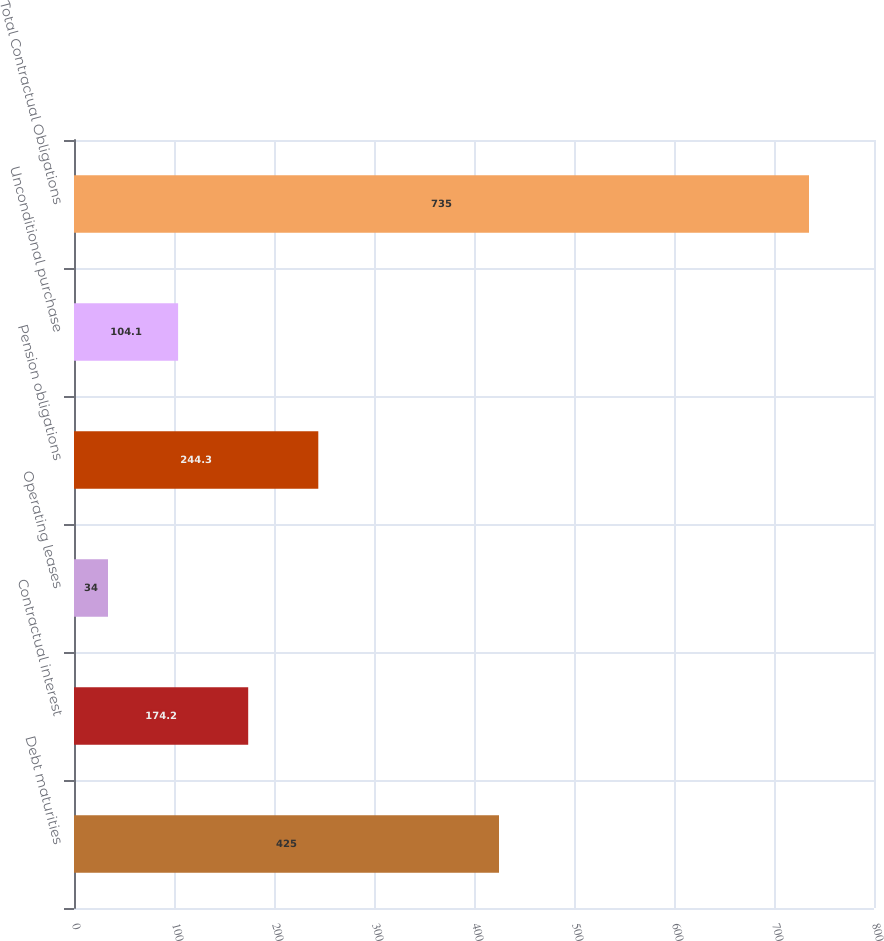Convert chart. <chart><loc_0><loc_0><loc_500><loc_500><bar_chart><fcel>Debt maturities<fcel>Contractual interest<fcel>Operating leases<fcel>Pension obligations<fcel>Unconditional purchase<fcel>Total Contractual Obligations<nl><fcel>425<fcel>174.2<fcel>34<fcel>244.3<fcel>104.1<fcel>735<nl></chart> 